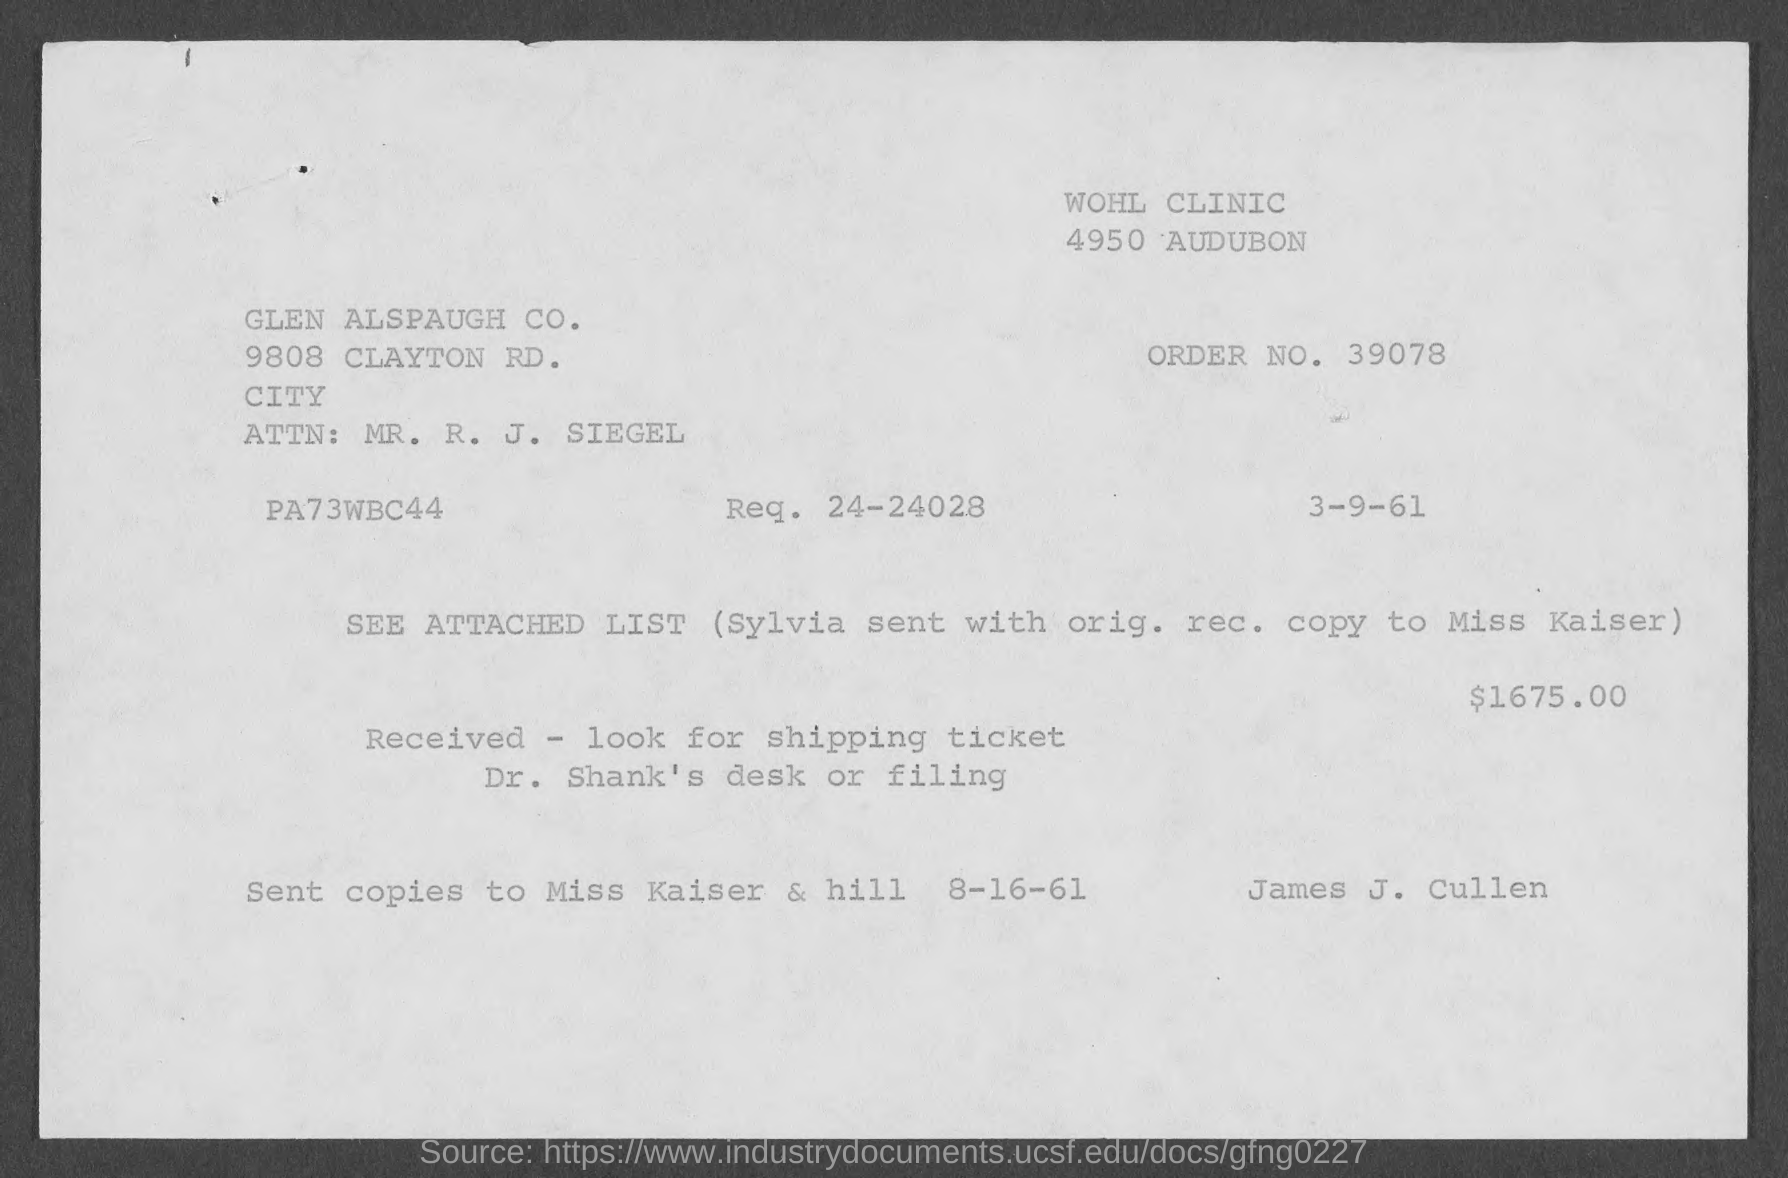Specify some key components in this picture. The requested number mentioned on the given page is 24-24028. The order number mentioned on the given page is 39078. 